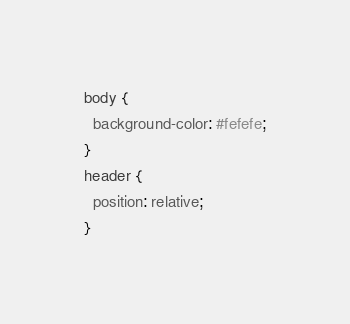<code> <loc_0><loc_0><loc_500><loc_500><_CSS_>body {
  background-color: #fefefe;
}
header {
  position: relative;
}
</code> 